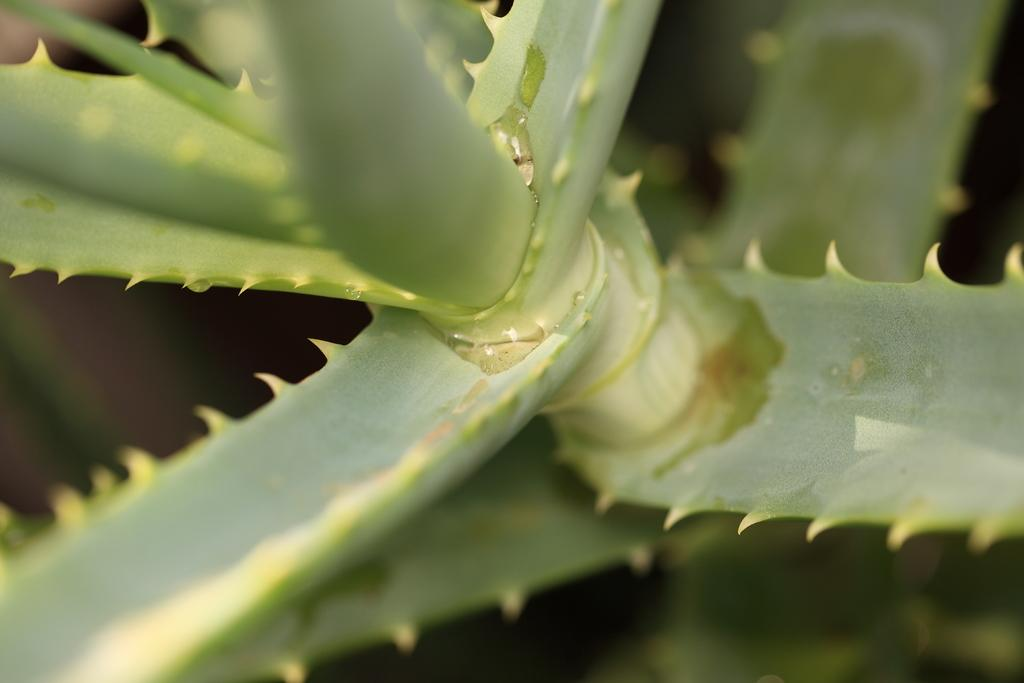What is present in the image? There is a plant in the image. What can be said about the color of the plant? The plant is green in color. What does the plant say with its mouth in the image? Plants do not have mouths, so they cannot speak or express thoughts in the image. 